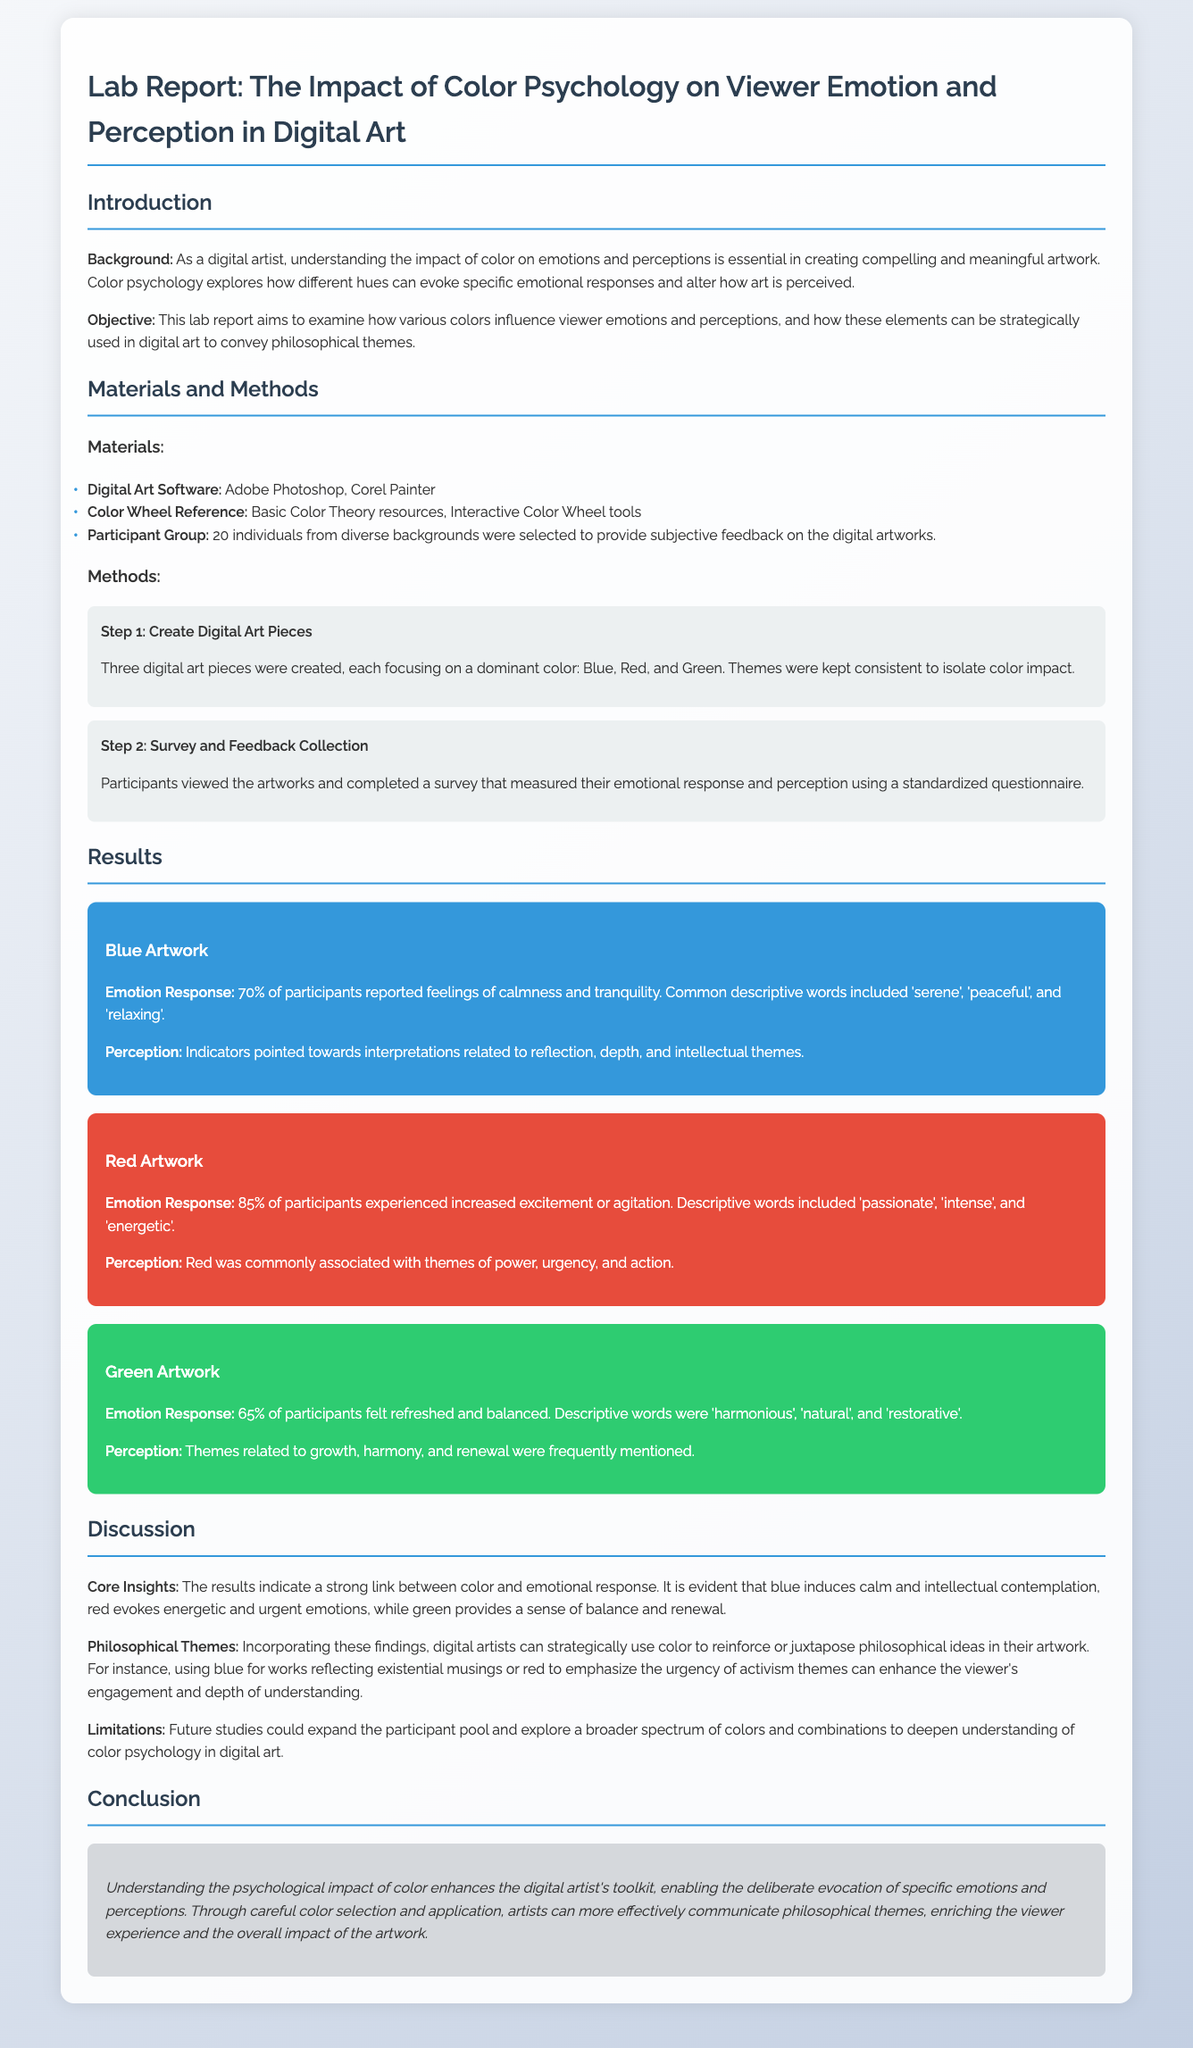What was the background of the report? The background explains the importance of understanding color impact on emotions and perceptions in creating digital artwork.
Answer: Understanding the impact of color on emotions and perceptions What percentage of participants felt calmness in response to blue? The document states that 70% of participants reported feelings of calmness and tranquility.
Answer: 70% What colors were used in the digital art pieces? The report specifies three dominant colors used in the artworks: Blue, Red, and Green.
Answer: Blue, Red, Green What descriptive words were associated with red artwork? The document lists descriptive words including 'passionate', 'intense', and 'energetic'.
Answer: passionate, intense, energetic What is one limitation mentioned in the report? The report suggests that future studies could expand the participant pool.
Answer: Expand the participant pool What was the objective of the lab report? The document's objective was to examine how various colors influence viewer emotions and perceptions.
Answer: Examine how various colors influence viewer emotions and perceptions What kind of participants were selected for the study? The document states that 20 individuals from diverse backgrounds were selected to provide feedback.
Answer: 20 individuals from diverse backgrounds How did green artwork affect participants emotionally? The report mentions that 65% of participants felt refreshed and balanced from the green artwork.
Answer: 65% of participants felt refreshed and balanced 